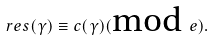Convert formula to latex. <formula><loc_0><loc_0><loc_500><loc_500>r e s ( \gamma ) \equiv c ( \gamma ) ( \text {mod } e ) .</formula> 